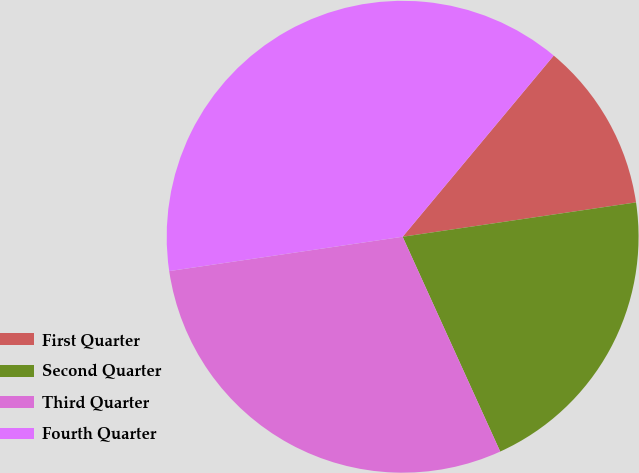<chart> <loc_0><loc_0><loc_500><loc_500><pie_chart><fcel>First Quarter<fcel>Second Quarter<fcel>Third Quarter<fcel>Fourth Quarter<nl><fcel>11.61%<fcel>20.54%<fcel>29.46%<fcel>38.39%<nl></chart> 